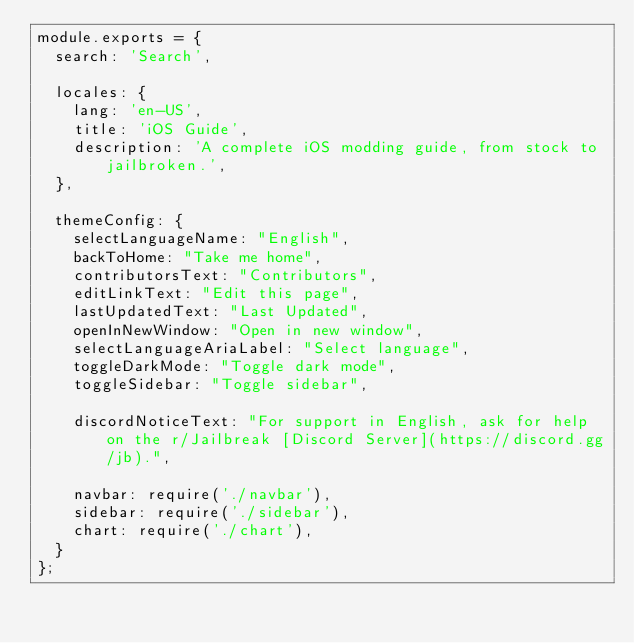Convert code to text. <code><loc_0><loc_0><loc_500><loc_500><_JavaScript_>module.exports = {
  search: 'Search',
  
  locales: {
    lang: 'en-US',
    title: 'iOS Guide',
    description: 'A complete iOS modding guide, from stock to jailbroken.',
  },
  
  themeConfig: {
  	selectLanguageName: "English",
  	backToHome: "Take me home",
  	contributorsText: "Contributors",
  	editLinkText: "Edit this page",
  	lastUpdatedText: "Last Updated",
  	openInNewWindow: "Open in new window",
  	selectLanguageAriaLabel: "Select language",
  	toggleDarkMode: "Toggle dark mode",
  	toggleSidebar: "Toggle sidebar",
    
    discordNoticeText: "For support in English, ask for help on the r/Jailbreak [Discord Server](https://discord.gg/jb).",
      
    navbar: require('./navbar'),
    sidebar: require('./sidebar'),
    chart: require('./chart'),
  }
};</code> 